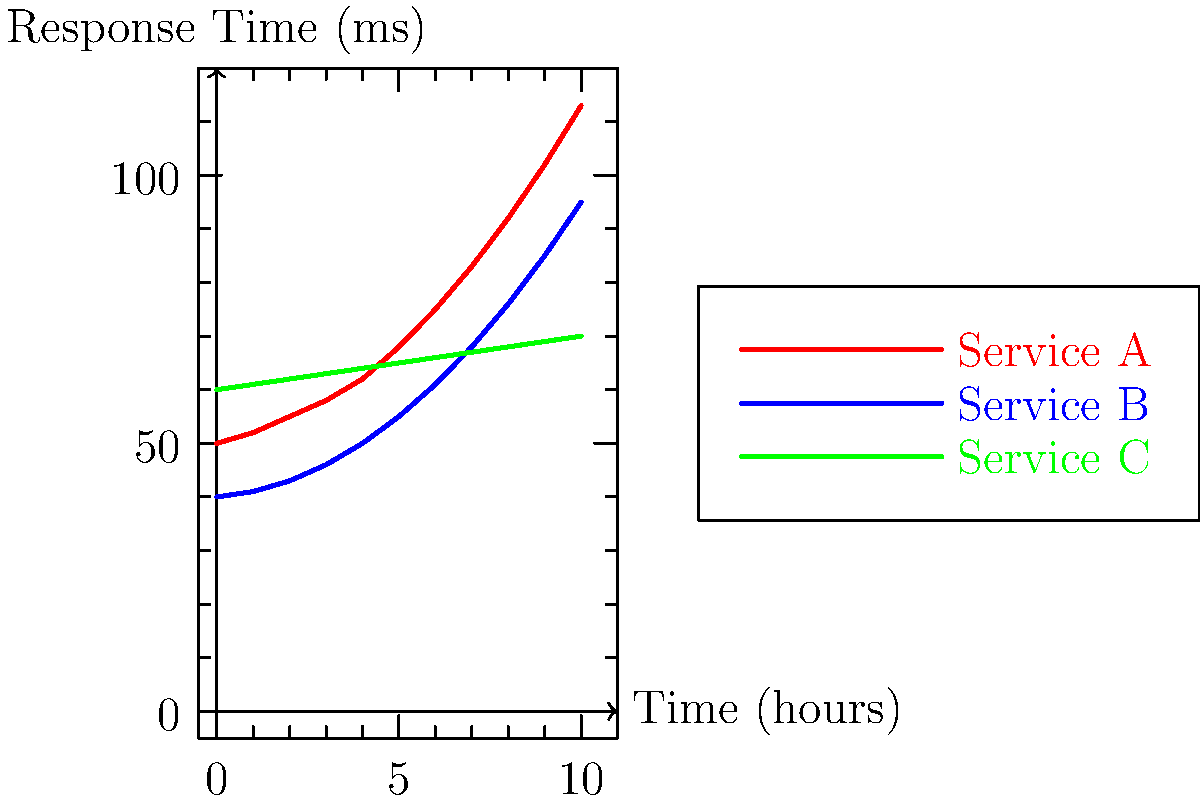Based on the line graph showing response times of different microservices over a 10-hour period, which service exhibits the most concerning trend in terms of scalability and performance, and why? To determine which service exhibits the most concerning trend in terms of scalability and performance, we need to analyze the response time patterns for each service:

1. Service A (red line):
   - Starts at 50ms and ends at 113ms
   - Shows a rapid, exponential increase in response time
   - The slope of the line is steepening, indicating accelerating degradation

2. Service B (blue line):
   - Starts at 40ms and ends at 95ms
   - Also shows an increasing trend, but less steep than Service A
   - The slope is gradually increasing, suggesting a slower performance degradation

3. Service C (green line):
   - Starts at 60ms and ends at 70ms
   - Shows a linear, very gradual increase in response time
   - The slope is constant and relatively flat

Comparing these trends:
- Service A has the steepest increase and is accelerating the fastest
- Service B is also increasing but at a slower rate than A
- Service C maintains a nearly constant response time with only a slight increase

The most concerning trend is exhibited by Service A because:
1. It shows the largest absolute increase in response time (63ms over 10 hours)
2. The rate of increase is accelerating, suggesting potential scalability issues
3. If this trend continues, it will quickly become unusable, impacting overall system performance

This exponential growth in response time for Service A indicates it may not be scaling well with increased load or time, which is a critical concern for microservices architecture.
Answer: Service A, due to its exponential increase in response time, indicating poor scalability. 